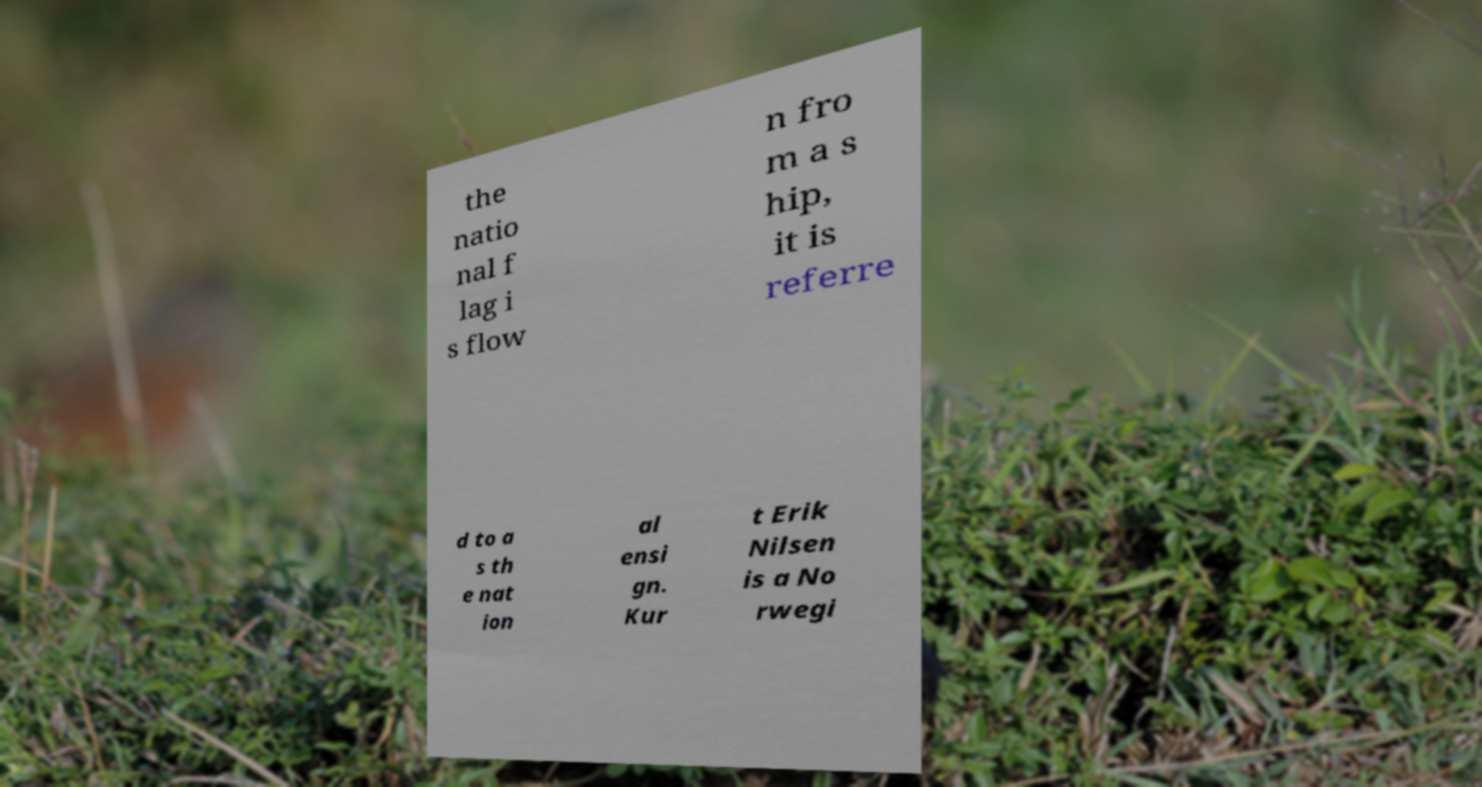There's text embedded in this image that I need extracted. Can you transcribe it verbatim? the natio nal f lag i s flow n fro m a s hip, it is referre d to a s th e nat ion al ensi gn. Kur t Erik Nilsen is a No rwegi 